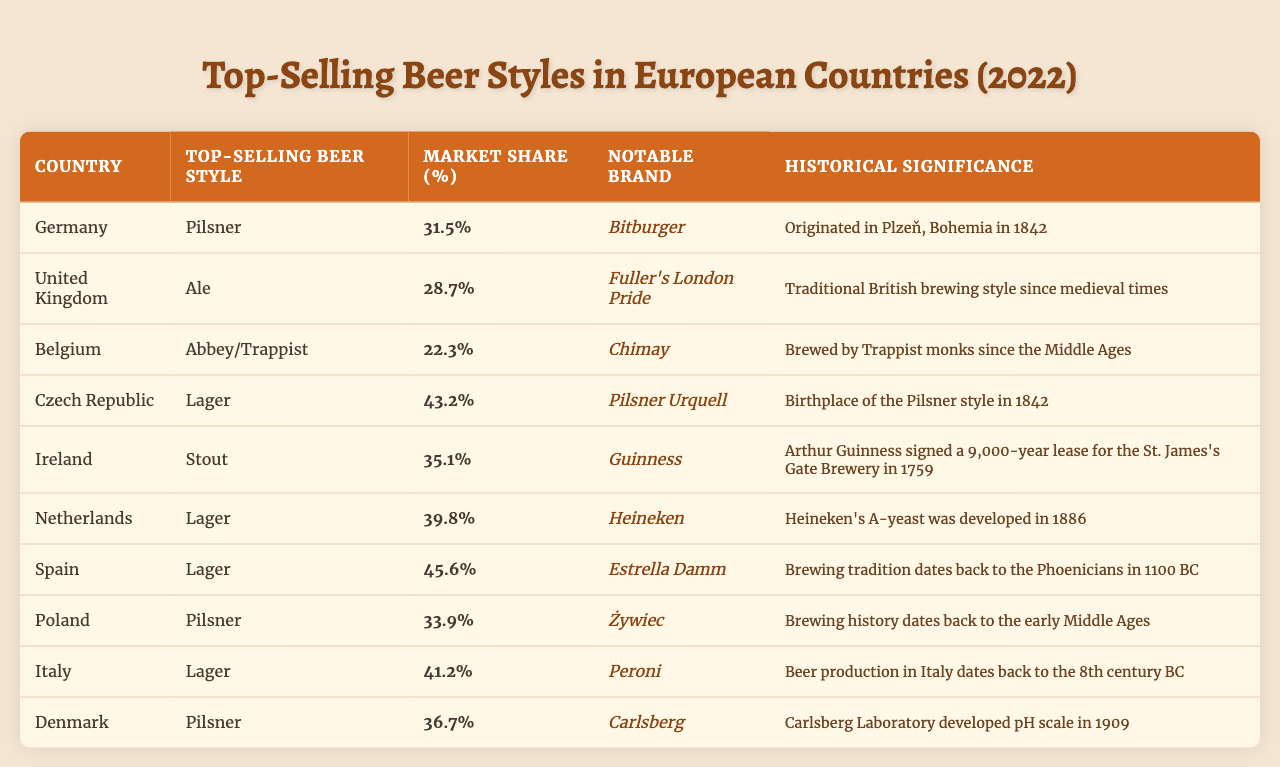What is the top-selling beer style in Germany? According to the table, the top-selling beer style in Germany is Pilsner, which is listed under the "Top-Selling Beer Style" column corresponding to Germany.
Answer: Pilsner What market share does the top-selling beer style in Belgium have? The table shows that the market share for Abbey/Trappist in Belgium is 22.3%, as noted in the "Market Share (%)" column for Belgium.
Answer: 22.3% Which country has the highest market share for Lager? To find the country with the highest market share for Lager, we compare the values in the "Market Share (%)" column for Lager entries: Czech Republic (43.2), Netherlands (39.8), and Spain (45.6). Spain has the highest value at 45.6%.
Answer: Spain Is the notable brand for Pilsner in Germany Bitburger? Looking at the "Notable Brand" column for Germany, it indeed lists Bitburger as the notable brand for the Pilsner style.
Answer: Yes Which beer style has a notable brand of Guinness? The table indicates that Stout is the beer style associated with the notable brand Guinness, found in the entry for Ireland.
Answer: Stout What is the average market share of Lager across the listed countries? The market shares for Lager in the table are: Czech Republic (43.2), Netherlands (39.8), and Spain (45.6). To find the average, we sum these values (43.2 + 39.8 + 45.6 = 128.6) and then divide by the number of entries (3). Therefore, the average is 128.6 / 3 = 42.87%.
Answer: 42.87% Which beer styles have a market share above 30% in the provided data? We need to identify all entries in the "Market Share (%)" column that exceed 30%. From the data: Germany (31.5), France (35.1), Netherlands (39.8), Spain (45.6), and others meet this condition. The beer styles are Pilsner, Stout, and Lager.
Answer: Pilsner, Stout, Lager In which country do Trappist beers have historical significance? The historical significance for Abbey/Trappist beers is recorded in the table for Belgium, noting that they are brewed by Trappist monks since the Middle Ages.
Answer: Belgium What is the notable brand for the top-selling beer style in Italy? Referring to the "Notable Brand" column for Italy, we see that the top-selling beer style of Lager is associated with the notable brand Peroni.
Answer: Peroni Which beer style is the top seller in Poland and what is its market share? According to the table, the top-selling beer style in Poland is Pilsner with a market share of 33.9%.
Answer: Pilsner, 33.9% 